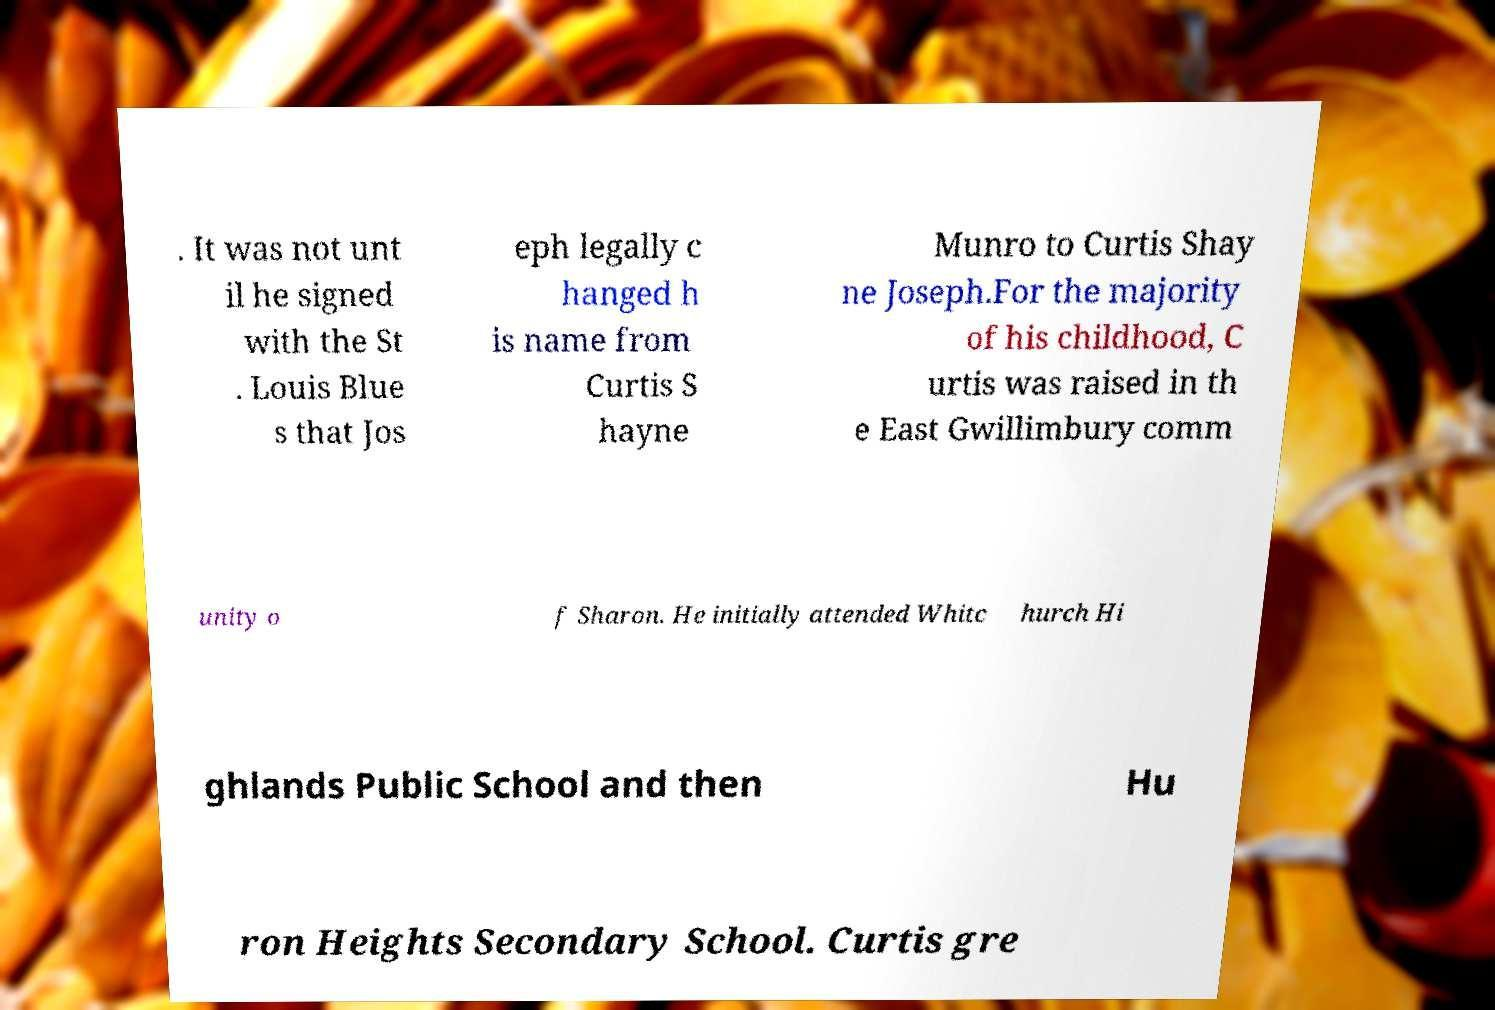Could you assist in decoding the text presented in this image and type it out clearly? . It was not unt il he signed with the St . Louis Blue s that Jos eph legally c hanged h is name from Curtis S hayne Munro to Curtis Shay ne Joseph.For the majority of his childhood, C urtis was raised in th e East Gwillimbury comm unity o f Sharon. He initially attended Whitc hurch Hi ghlands Public School and then Hu ron Heights Secondary School. Curtis gre 